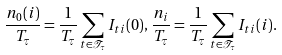Convert formula to latex. <formula><loc_0><loc_0><loc_500><loc_500>\frac { n _ { 0 } ( i ) } { T _ { \tau } } = \frac { 1 } { T _ { \tau } } \sum _ { t \in \mathcal { T } _ { \tau } } I _ { t i } ( 0 ) , \, \frac { n _ { i } } { T _ { \tau } } = \frac { 1 } { T _ { \tau } } \sum _ { t \in \mathcal { T } _ { \tau } } I _ { t i } ( i ) .</formula> 